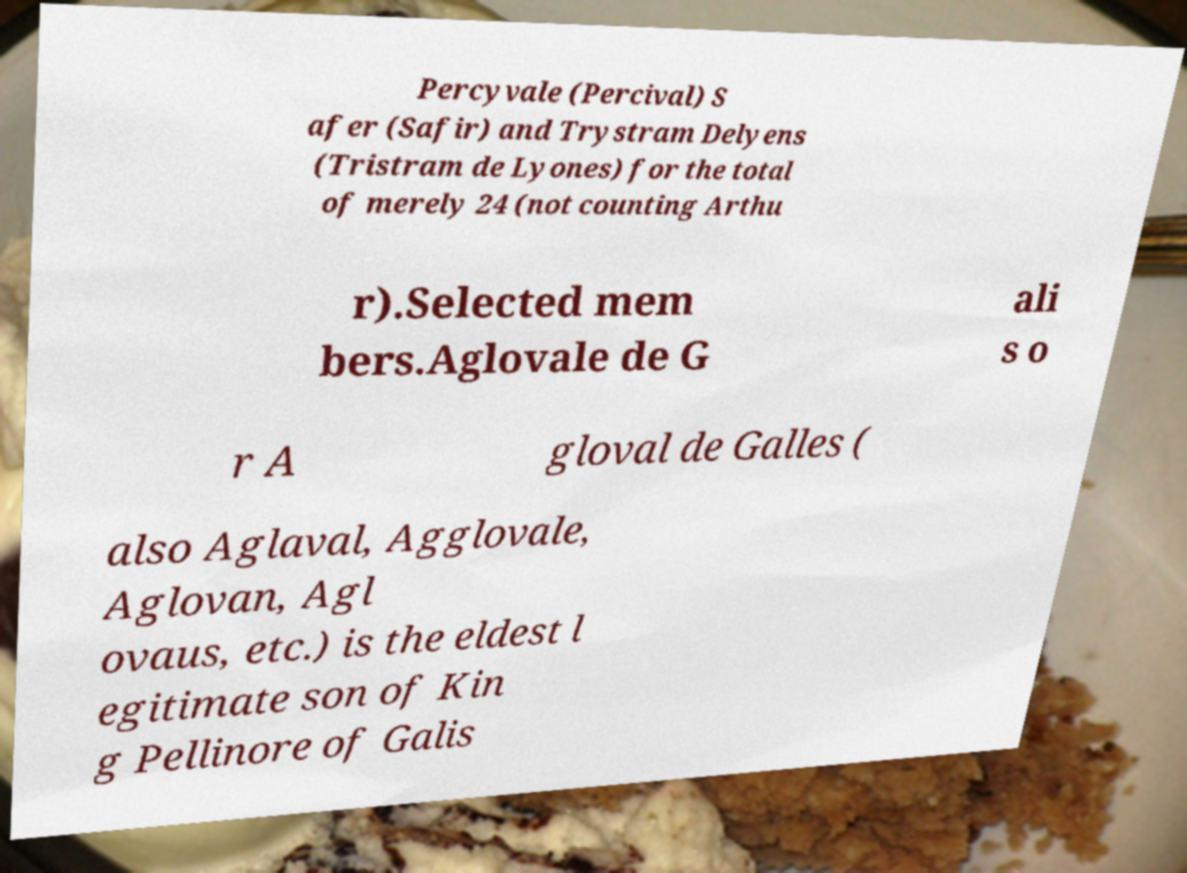I need the written content from this picture converted into text. Can you do that? Percyvale (Percival) S afer (Safir) and Trystram Delyens (Tristram de Lyones) for the total of merely 24 (not counting Arthu r).Selected mem bers.Aglovale de G ali s o r A gloval de Galles ( also Aglaval, Agglovale, Aglovan, Agl ovaus, etc.) is the eldest l egitimate son of Kin g Pellinore of Galis 